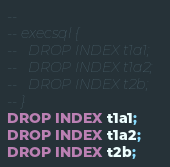Convert code to text. <code><loc_0><loc_0><loc_500><loc_500><_SQL_>-- 
-- execsql {
--   DROP INDEX t1a1;
--   DROP INDEX t1a2;
--   DROP INDEX t2b;
-- }
DROP INDEX t1a1;
DROP INDEX t1a2;
DROP INDEX t2b;</code> 